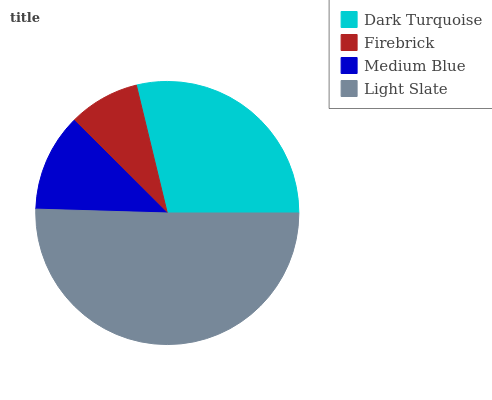Is Firebrick the minimum?
Answer yes or no. Yes. Is Light Slate the maximum?
Answer yes or no. Yes. Is Medium Blue the minimum?
Answer yes or no. No. Is Medium Blue the maximum?
Answer yes or no. No. Is Medium Blue greater than Firebrick?
Answer yes or no. Yes. Is Firebrick less than Medium Blue?
Answer yes or no. Yes. Is Firebrick greater than Medium Blue?
Answer yes or no. No. Is Medium Blue less than Firebrick?
Answer yes or no. No. Is Dark Turquoise the high median?
Answer yes or no. Yes. Is Medium Blue the low median?
Answer yes or no. Yes. Is Light Slate the high median?
Answer yes or no. No. Is Light Slate the low median?
Answer yes or no. No. 